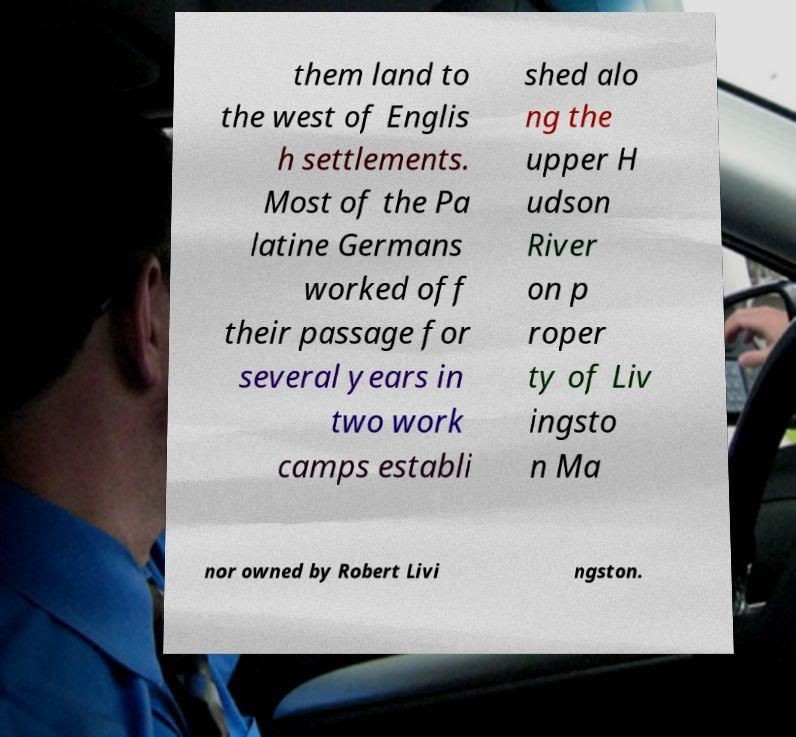I need the written content from this picture converted into text. Can you do that? them land to the west of Englis h settlements. Most of the Pa latine Germans worked off their passage for several years in two work camps establi shed alo ng the upper H udson River on p roper ty of Liv ingsto n Ma nor owned by Robert Livi ngston. 